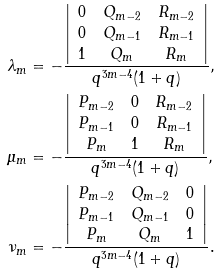<formula> <loc_0><loc_0><loc_500><loc_500>\lambda _ { m } & = - \frac { \left | \begin{array} { c c c } 0 & Q _ { m - 2 } & R _ { m - 2 } \\ 0 & Q _ { m - 1 } & R _ { m - 1 } \\ 1 & Q _ { m } & R _ { m } \\ \end{array} \right | } { q ^ { 3 m - 4 } ( 1 + q ) } , \\ \mu _ { m } & = - \frac { \left | \begin{array} { c c c } P _ { m - 2 } & 0 & R _ { m - 2 } \\ P _ { m - 1 } & 0 & R _ { m - 1 } \\ P _ { m } & 1 & R _ { m } \\ \end{array} \right | } { q ^ { 3 m - 4 } ( 1 + q ) } , \\ \nu _ { m } & = - \frac { \left | \begin{array} { c c c } P _ { m - 2 } & Q _ { m - 2 } & 0 \\ P _ { m - 1 } & Q _ { m - 1 } & 0 \\ P _ { m } & Q _ { m } & 1 \\ \end{array} \right | } { q ^ { 3 m - 4 } ( 1 + q ) } .</formula> 